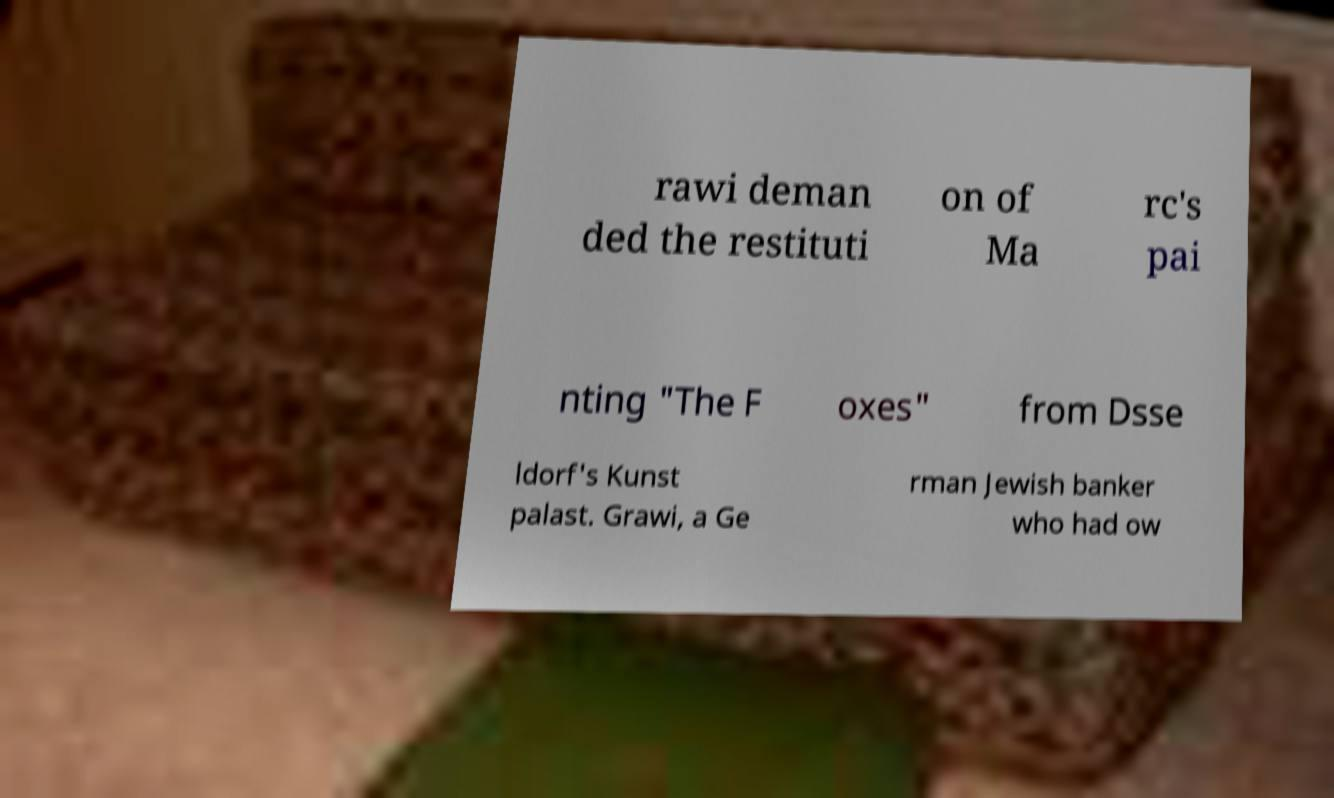Can you read and provide the text displayed in the image?This photo seems to have some interesting text. Can you extract and type it out for me? rawi deman ded the restituti on of Ma rc's pai nting "The F oxes" from Dsse ldorf's Kunst palast. Grawi, a Ge rman Jewish banker who had ow 